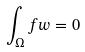<formula> <loc_0><loc_0><loc_500><loc_500>\int _ { \Omega } f w = 0</formula> 